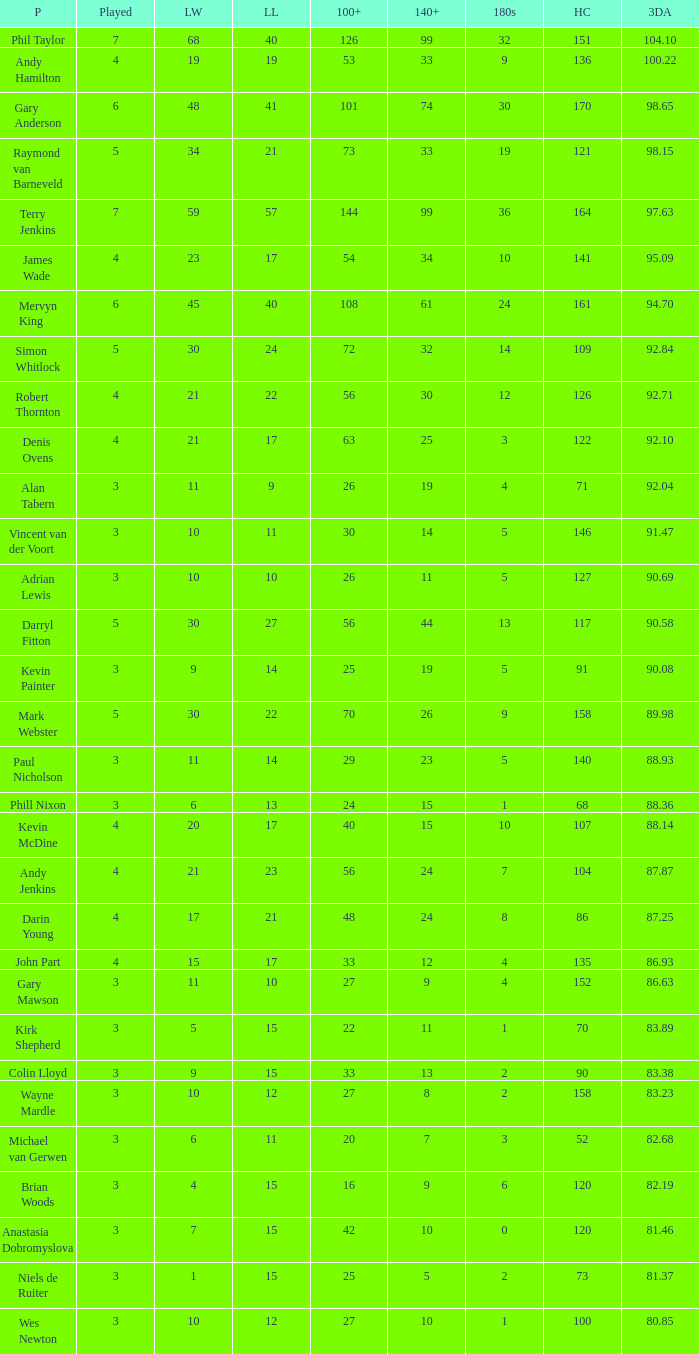Who is the player with 41 legs lost? Gary Anderson. 